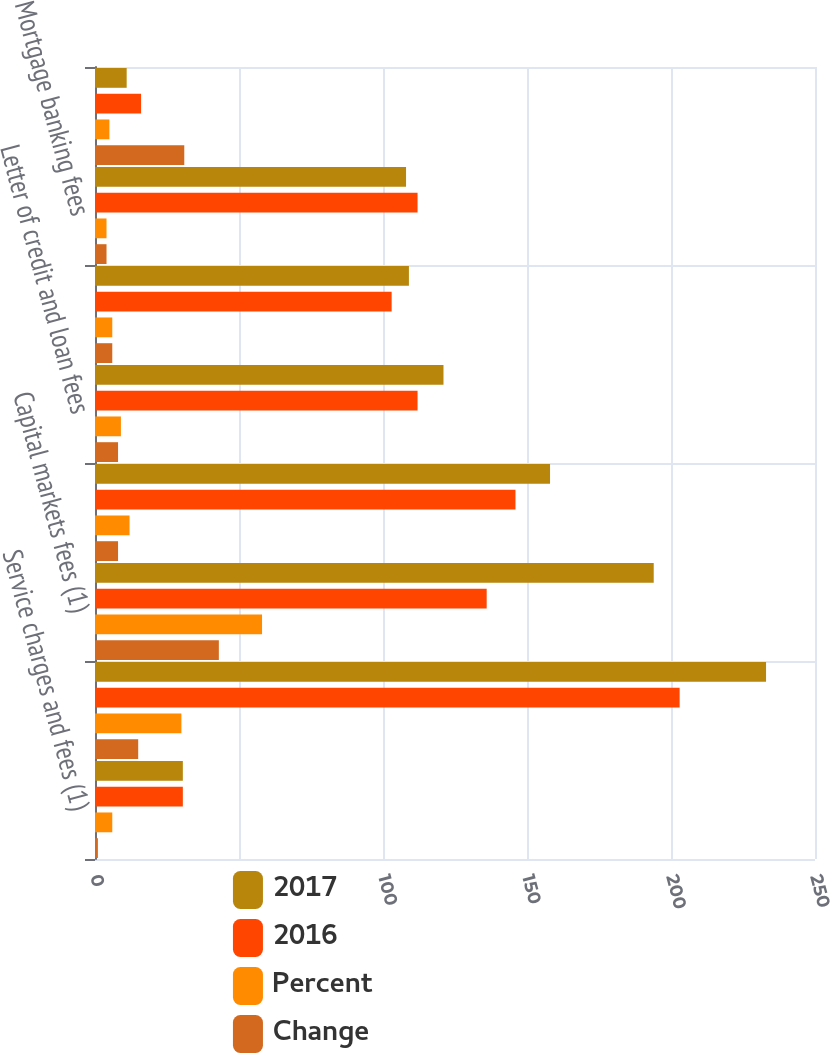Convert chart. <chart><loc_0><loc_0><loc_500><loc_500><stacked_bar_chart><ecel><fcel>Service charges and fees (1)<fcel>Card fees<fcel>Capital markets fees (1)<fcel>Trust and investment services<fcel>Letter of credit and loan fees<fcel>Foreign exchange and interest<fcel>Mortgage banking fees<fcel>Securities gains net<nl><fcel>2017<fcel>30.5<fcel>233<fcel>194<fcel>158<fcel>121<fcel>109<fcel>108<fcel>11<nl><fcel>2016<fcel>30.5<fcel>203<fcel>136<fcel>146<fcel>112<fcel>103<fcel>112<fcel>16<nl><fcel>Percent<fcel>6<fcel>30<fcel>58<fcel>12<fcel>9<fcel>6<fcel>4<fcel>5<nl><fcel>Change<fcel>1<fcel>15<fcel>43<fcel>8<fcel>8<fcel>6<fcel>4<fcel>31<nl></chart> 